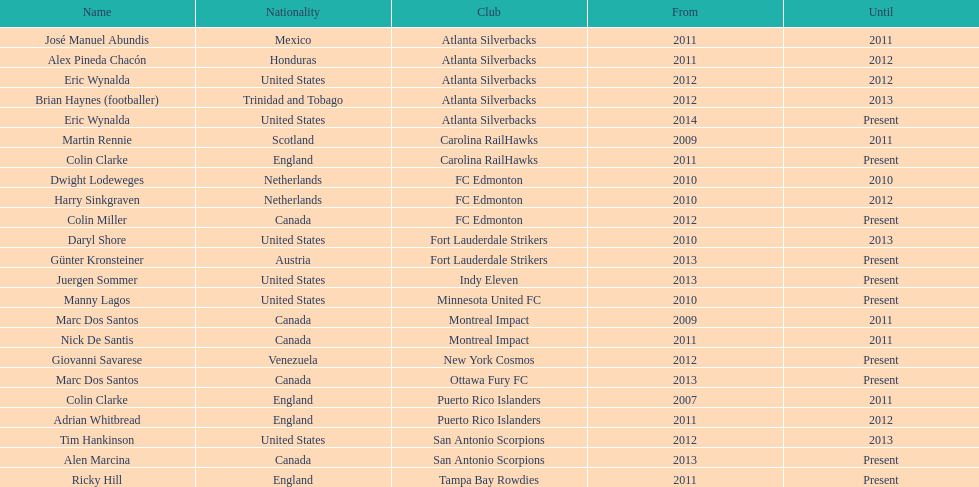Who was the manager of fc edmonton before miller? Harry Sinkgraven. 